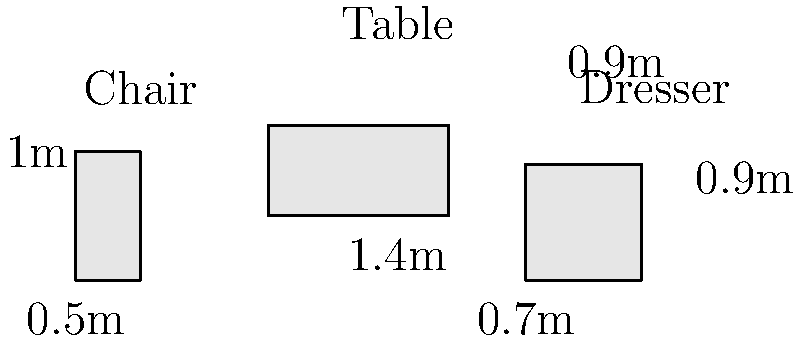Given the dimensions of the antique furniture items shown in the image, estimate the total volume of packing material required to safely transport all three pieces. Assume that each item needs an extra 10 cm of padding on all sides for protection. Round your answer to the nearest cubic meter. Let's calculate the volume for each furniture item, including the extra padding:

1. Chair:
   - Dimensions: $0.5\text{m} \times 0.5\text{m} \times 1\text{m}$
   - With padding: $(0.5 + 0.2)\text{m} \times (0.5 + 0.2)\text{m} \times (1 + 0.2)\text{m}$
   - Volume: $0.7\text{m} \times 0.7\text{m} \times 1.2\text{m} = 0.588\text{m}^3$

2. Table:
   - Dimensions: $1.4\text{m} \times 0.7\text{m} \times 0.7\text{m}$
   - With padding: $(1.4 + 0.2)\text{m} \times (0.7 + 0.2)\text{m} \times (0.7 + 0.2)\text{m}$
   - Volume: $1.6\text{m} \times 0.9\text{m} \times 0.9\text{m} = 1.296\text{m}^3$

3. Dresser:
   - Dimensions: $0.9\text{m} \times 0.9\text{m} \times 0.9\text{m}$
   - With padding: $(0.9 + 0.2)\text{m} \times (0.9 + 0.2)\text{m} \times (0.9 + 0.2)\text{m}$
   - Volume: $1.1\text{m} \times 1.1\text{m} \times 1.1\text{m} = 1.331\text{m}^3$

Total volume: $0.588\text{m}^3 + 1.296\text{m}^3 + 1.331\text{m}^3 = 3.215\text{m}^3$

Rounding to the nearest cubic meter: $3\text{m}^3$
Answer: $3\text{m}^3$ 